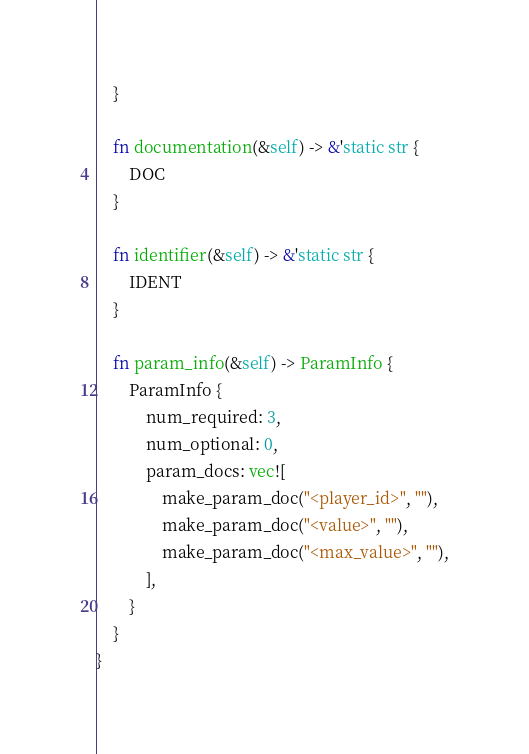Convert code to text. <code><loc_0><loc_0><loc_500><loc_500><_Rust_>    }

    fn documentation(&self) -> &'static str {
        DOC
    }

    fn identifier(&self) -> &'static str {
        IDENT
    }

    fn param_info(&self) -> ParamInfo {
        ParamInfo {
            num_required: 3,
            num_optional: 0,
            param_docs: vec![
                make_param_doc("<player_id>", ""),
                make_param_doc("<value>", ""),
                make_param_doc("<max_value>", ""),
            ],
        }
    }
}
</code> 